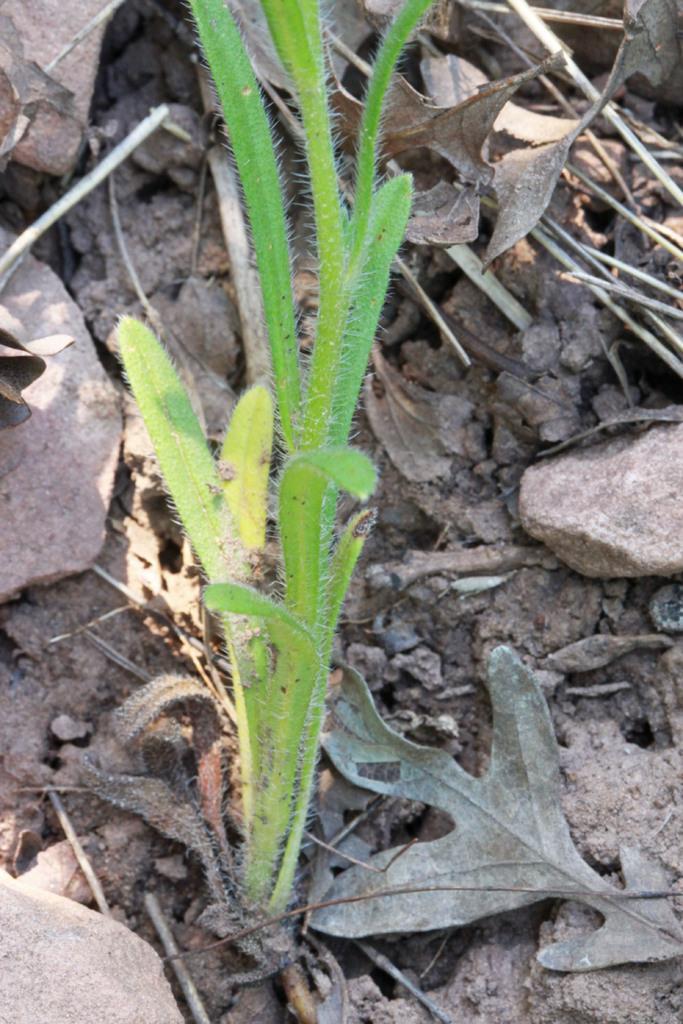Can you describe this image briefly? In the middle of the image we can see a plant. Behind the plant we can see some stones and leaves. 